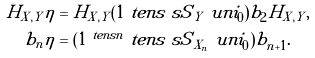<formula> <loc_0><loc_0><loc_500><loc_500>H _ { X , Y } \eta & = H _ { X , Y } ( 1 \ t e n s \ s S { _ { Y } } \ u n i _ { 0 } ) b _ { 2 } H _ { X , Y } , \\ b _ { n } \eta & = ( 1 ^ { \ t e n s n } \ t e n s \ s S { _ { X _ { n } } } \ u n i _ { 0 } ) b _ { n + 1 } .</formula> 